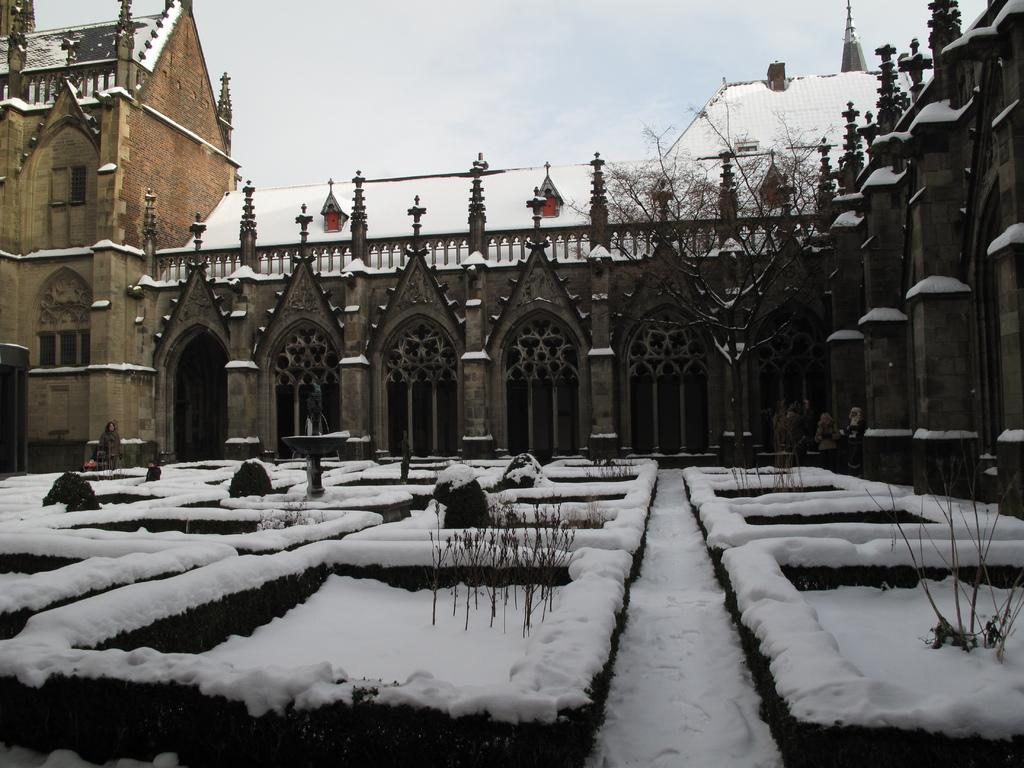What type of structures can be seen in the image? There are buildings in the image. What is the weather like in the image? There is snow visible in the image, indicating a cold or wintery environment. What type of vegetation is present in the image? There is a tree in the image. What is visible at the top of the image? The sky is visible at the top of the image. How many requests can be seen in the image? There are no requests visible in the image; it features buildings, snow, a tree, and the sky. Is there a sea visible in the image? No, there is no sea present in the image. 